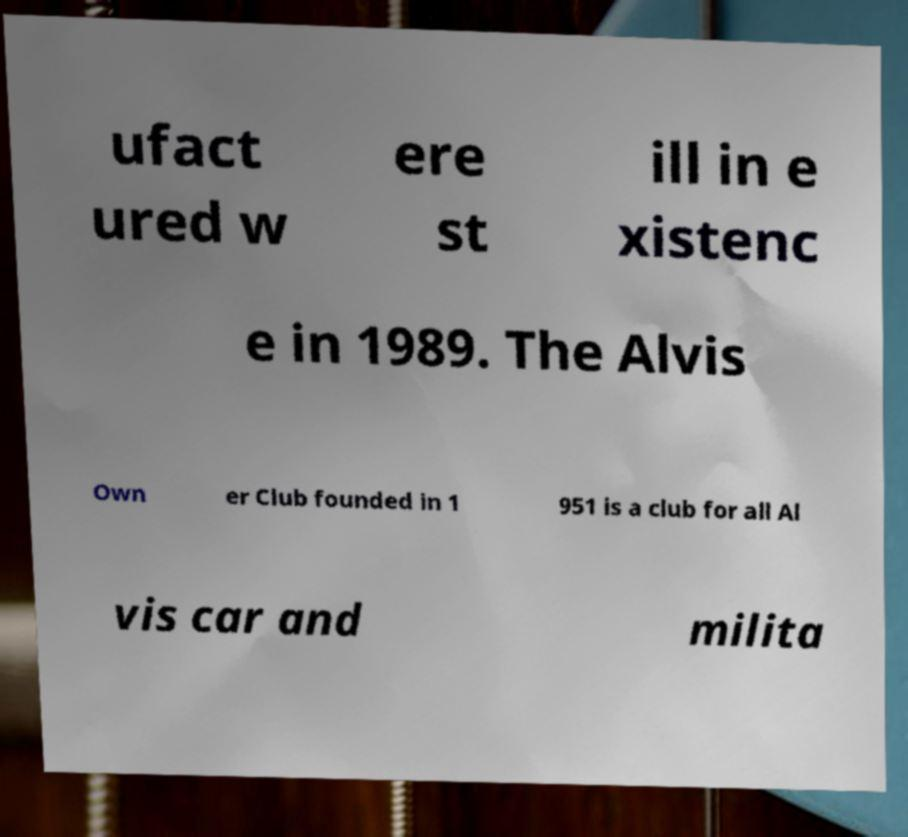Please identify and transcribe the text found in this image. ufact ured w ere st ill in e xistenc e in 1989. The Alvis Own er Club founded in 1 951 is a club for all Al vis car and milita 